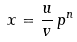<formula> <loc_0><loc_0><loc_500><loc_500>x = \frac { u } { v } \, p ^ { n }</formula> 